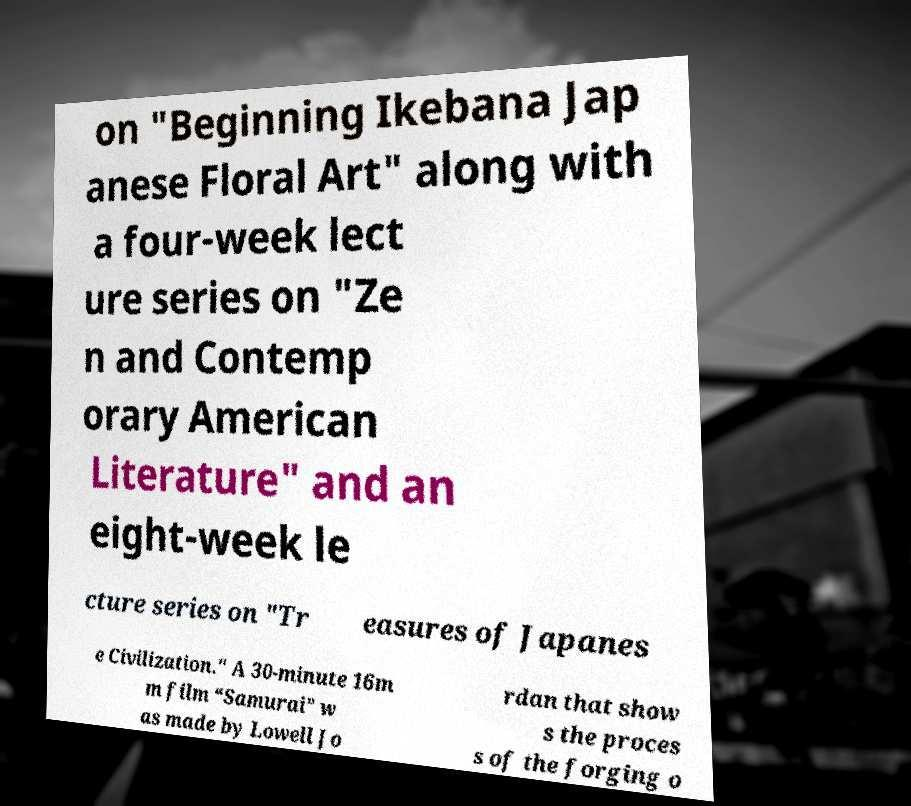Can you read and provide the text displayed in the image?This photo seems to have some interesting text. Can you extract and type it out for me? on "Beginning Ikebana Jap anese Floral Art" along with a four-week lect ure series on "Ze n and Contemp orary American Literature" and an eight-week le cture series on "Tr easures of Japanes e Civilization." A 30-minute 16m m film “Samurai” w as made by Lowell Jo rdan that show s the proces s of the forging o 